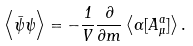<formula> <loc_0><loc_0><loc_500><loc_500>\left < \bar { \psi } \psi \right > = - \frac { 1 } { V } \frac { \partial } { \partial m } \left < \Gamma [ A ^ { a } _ { \mu } ] \right > .</formula> 